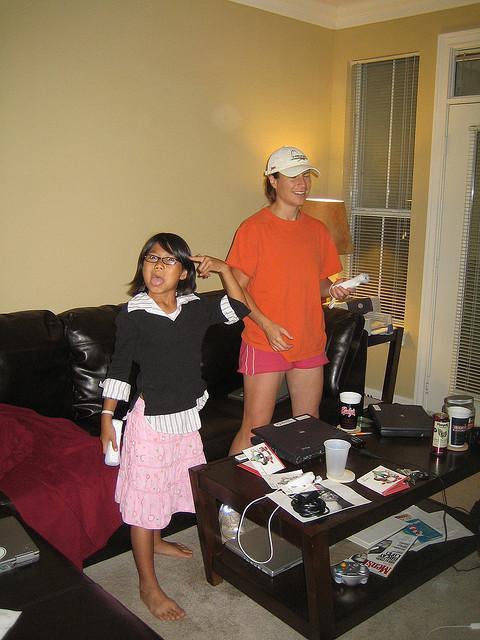How many cups are on the coffee table?
Give a very brief answer. 3. How many people are visible?
Give a very brief answer. 2. How many couches can you see?
Give a very brief answer. 2. How many silver cars are in the image?
Give a very brief answer. 0. 